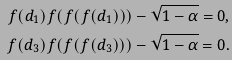<formula> <loc_0><loc_0><loc_500><loc_500>f ( d _ { 1 } ) f ( f ( f ( d _ { 1 } ) ) ) - \sqrt { 1 - \alpha } = 0 , \\ f ( d _ { 3 } ) f ( f ( f ( d _ { 3 } ) ) ) - \sqrt { 1 - \alpha } = 0 .</formula> 